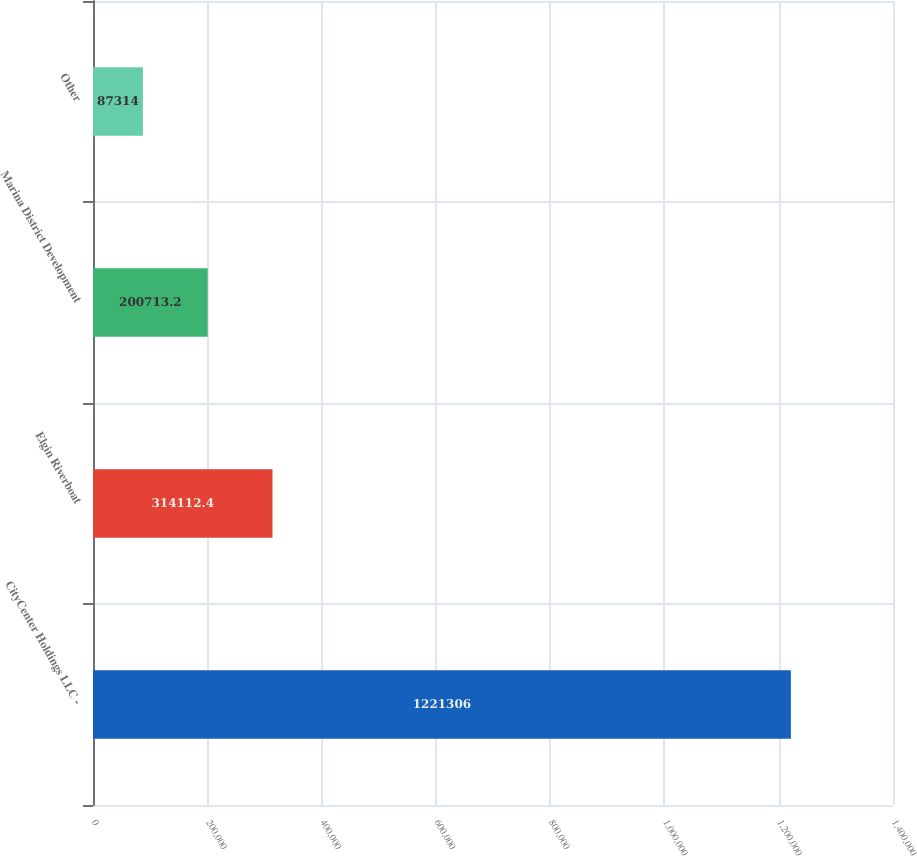Convert chart to OTSL. <chart><loc_0><loc_0><loc_500><loc_500><bar_chart><fcel>CityCenter Holdings LLC -<fcel>Elgin Riverboat<fcel>Marina District Development<fcel>Other<nl><fcel>1.22131e+06<fcel>314112<fcel>200713<fcel>87314<nl></chart> 